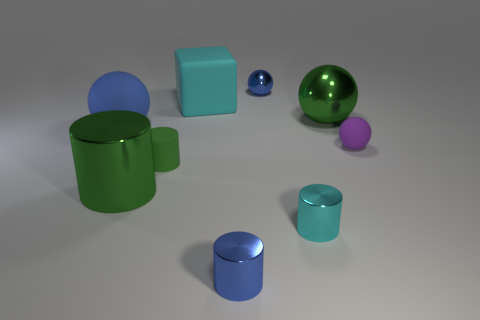Subtract all gray balls. Subtract all cyan cubes. How many balls are left? 4 Add 1 matte spheres. How many objects exist? 10 Subtract all cylinders. How many objects are left? 5 Add 5 big green cylinders. How many big green cylinders exist? 6 Subtract 1 green cylinders. How many objects are left? 8 Subtract all green things. Subtract all spheres. How many objects are left? 2 Add 2 green spheres. How many green spheres are left? 3 